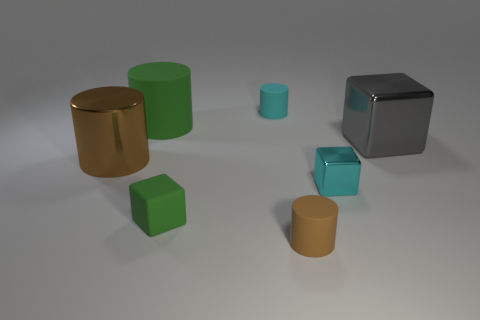If we were to add one more item to this scene to maintain a visual balance, what should it be and where would it be placed? Adding another metallic object could maintain balance. A metallic sphere placed to the right of the central grouping might complement the existing shapes and provide a contrast to the cylinders and cubes. 